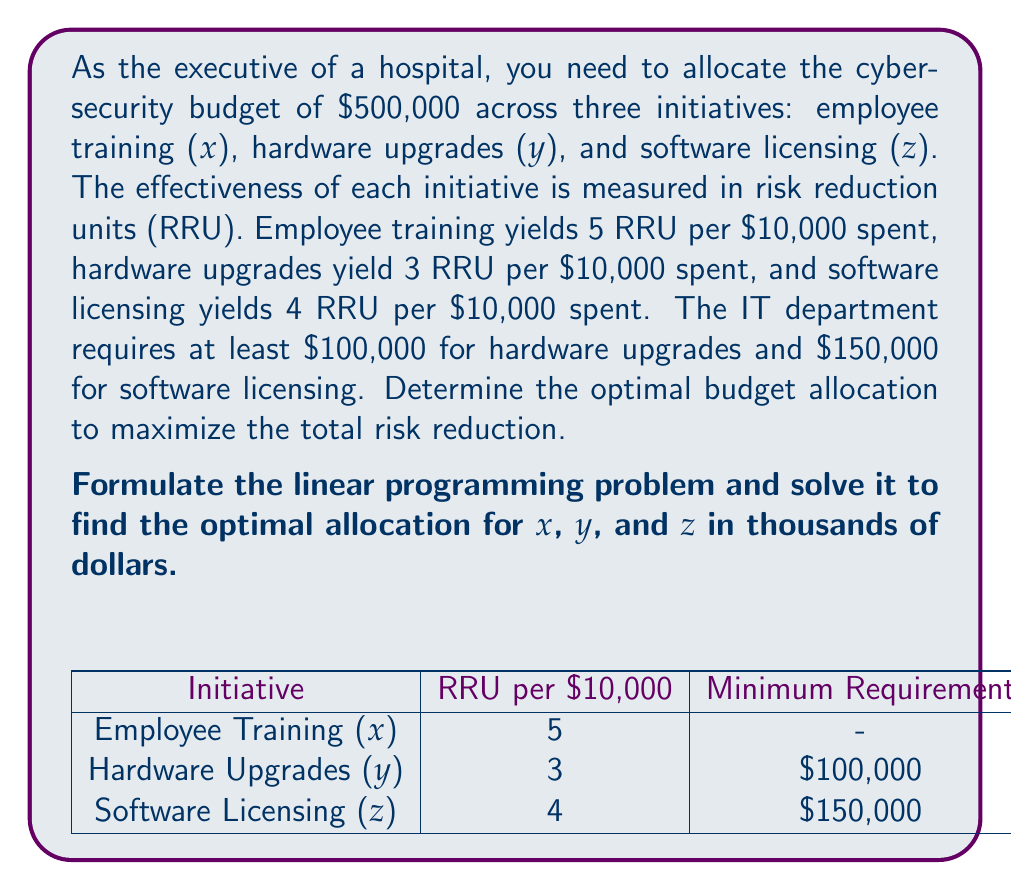Teach me how to tackle this problem. Let's approach this step-by-step:

1) First, we need to formulate the objective function. We want to maximize the total risk reduction:

   Maximize: $$ 5(\frac{x}{10}) + 3(\frac{y}{10}) + 4(\frac{z}{10}) $$

2) Now, let's identify the constraints:
   
   Total budget: $$ x + y + z \leq 500 $$
   Minimum for hardware: $$ y \geq 100 $$
   Minimum for software: $$ z \geq 150 $$
   Non-negativity: $$ x, y, z \geq 0 $$

3) Our linear programming problem is now:

   Maximize: $$ 0.5x + 0.3y + 0.4z $$
   Subject to:
   $$ x + y + z \leq 500 $$
   $$ y \geq 100 $$
   $$ z \geq 150 $$
   $$ x, y, z \geq 0 $$

4) To solve this, we can use the simplex method or a linear programming solver. The optimal solution is:

   $$ x = 250, y = 100, z = 150 $$

5) This allocation maximizes the objective function:

   $$ 0.5(250) + 0.3(100) + 0.4(150) = 125 + 30 + 60 = 215 $$

   The maximum risk reduction is 215 RRU.

6) To verify this is optimal, note that we've allocated the minimum required amounts to y and z, and put the remaining budget into x, which has the highest return per dollar.
Answer: Employee training: $250,000; Hardware upgrades: $100,000; Software licensing: $150,000 